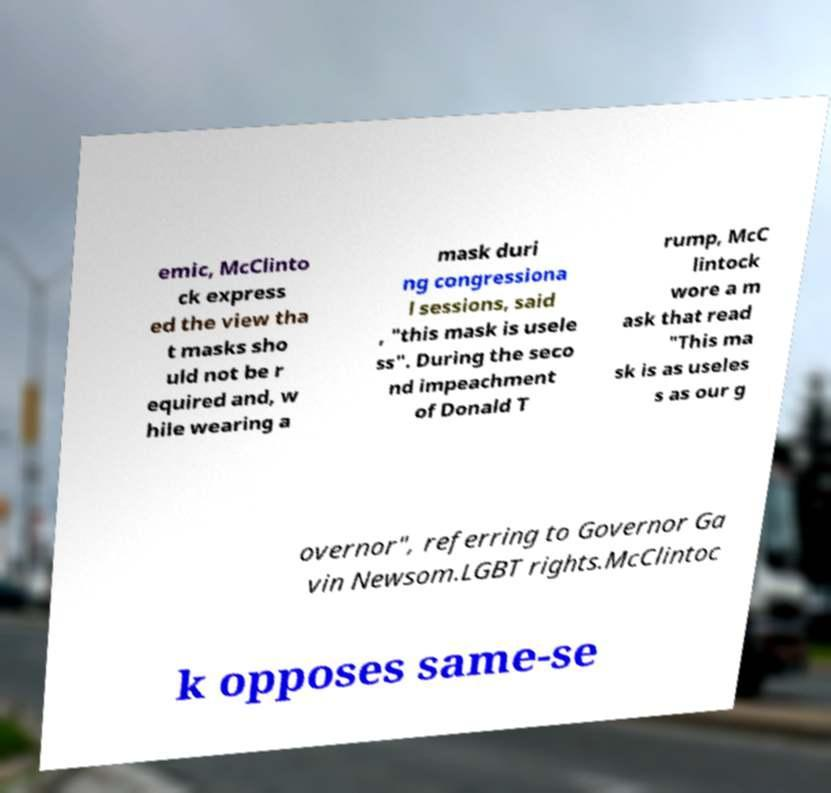Please read and relay the text visible in this image. What does it say? emic, McClinto ck express ed the view tha t masks sho uld not be r equired and, w hile wearing a mask duri ng congressiona l sessions, said , "this mask is usele ss". During the seco nd impeachment of Donald T rump, McC lintock wore a m ask that read "This ma sk is as useles s as our g overnor", referring to Governor Ga vin Newsom.LGBT rights.McClintoc k opposes same-se 